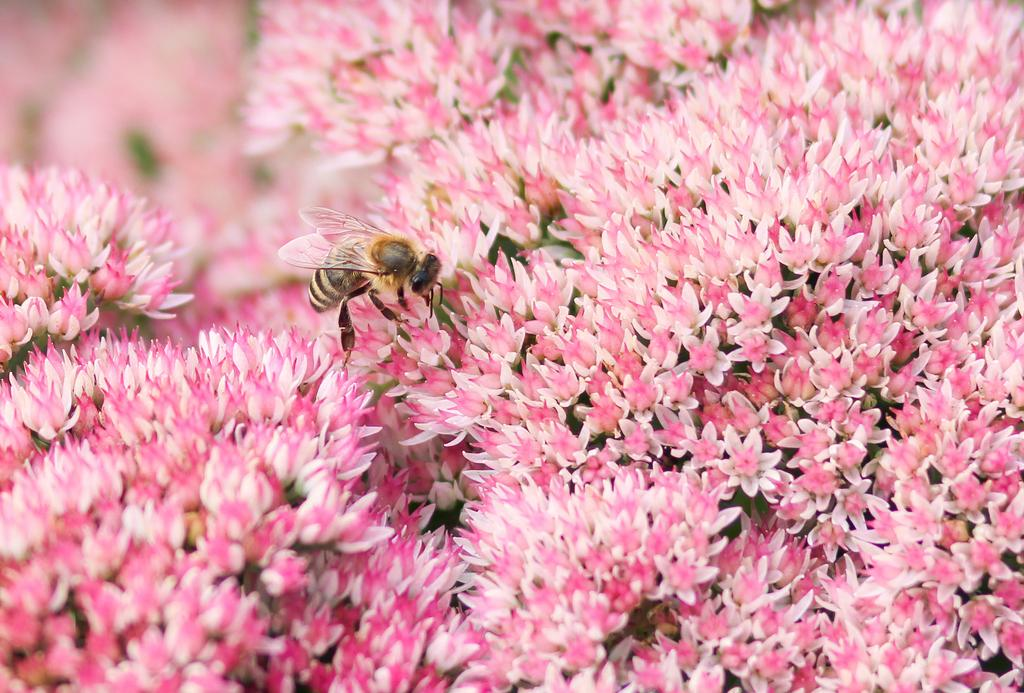What type of insect is present in the image? There is a bee in the image. Where is the bee located in relation to the flowers? The bee is on the flowers in the image. What type of plants are visible in the image? There are flowers in the image. What is the profit margin of the tramp in the image? There is no tramp present in the image, so it is not possible to determine the profit margin. 